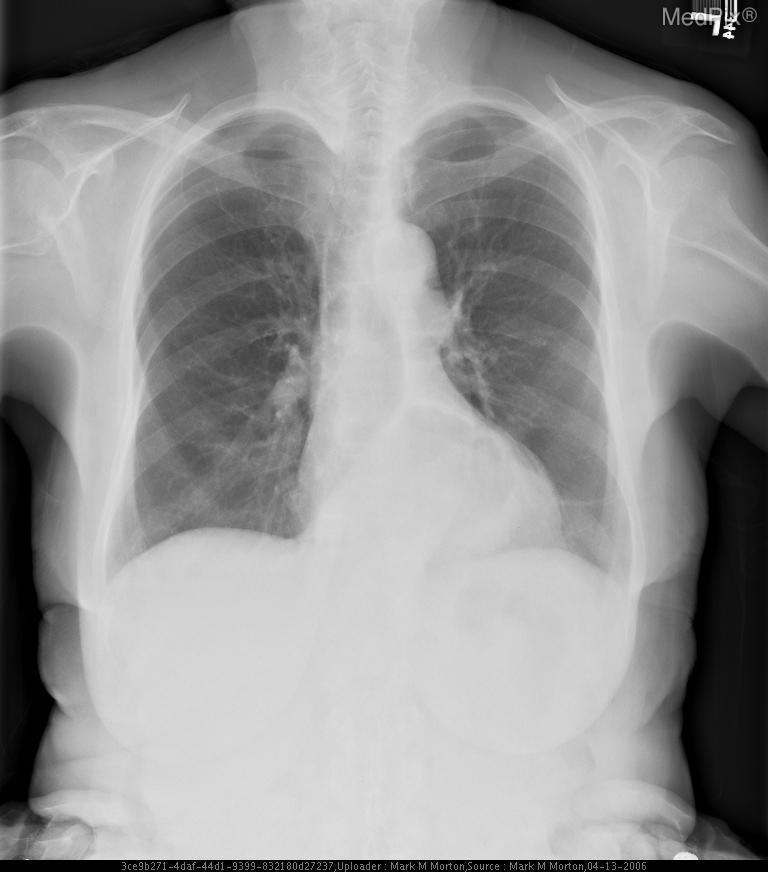What part of the body does this radiograph show?
Write a very short answer. Chest. The image has an abnormality located where?
Keep it brief. Retrocardiac. Where is the abnormality located in this image?
Keep it brief. Retrocardiac. The soft-tissue density seen in this image contains what?
Answer briefly. Air. What is filling the soft-tissue density seen in this image?
Answer briefly. Air. 